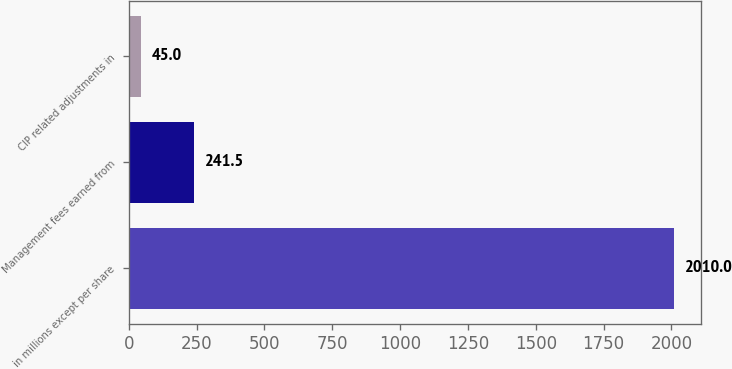Convert chart to OTSL. <chart><loc_0><loc_0><loc_500><loc_500><bar_chart><fcel>in millions except per share<fcel>Management fees earned from<fcel>CIP related adjustments in<nl><fcel>2010<fcel>241.5<fcel>45<nl></chart> 